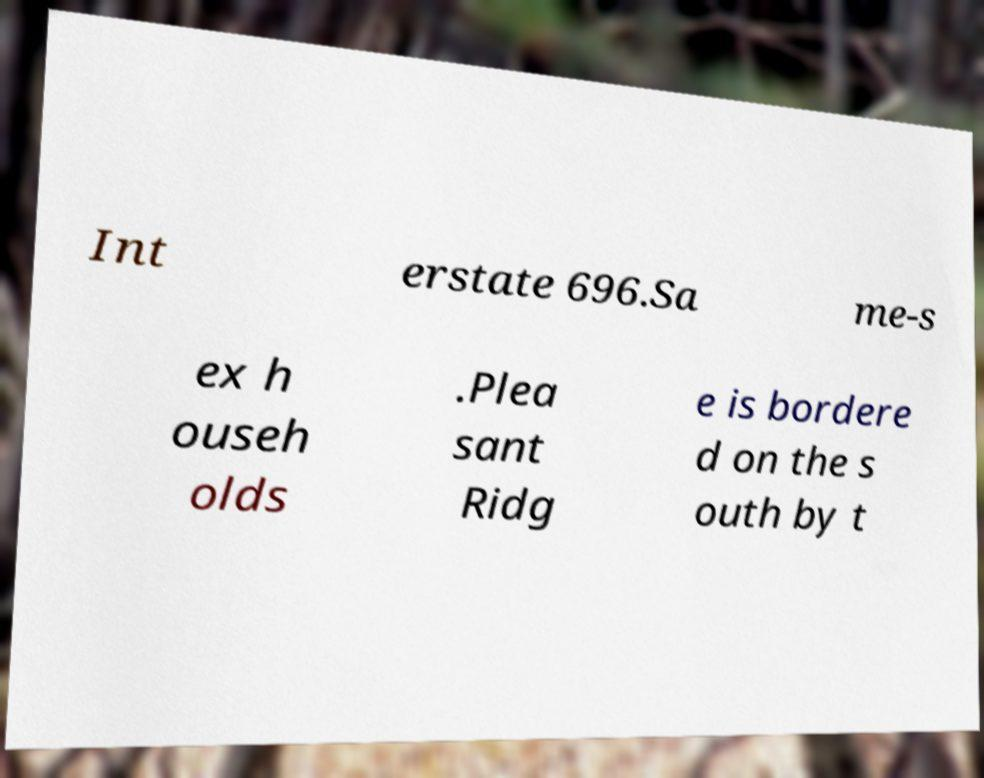What messages or text are displayed in this image? I need them in a readable, typed format. Int erstate 696.Sa me-s ex h ouseh olds .Plea sant Ridg e is bordere d on the s outh by t 